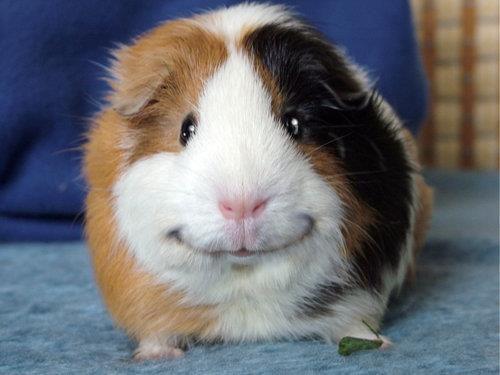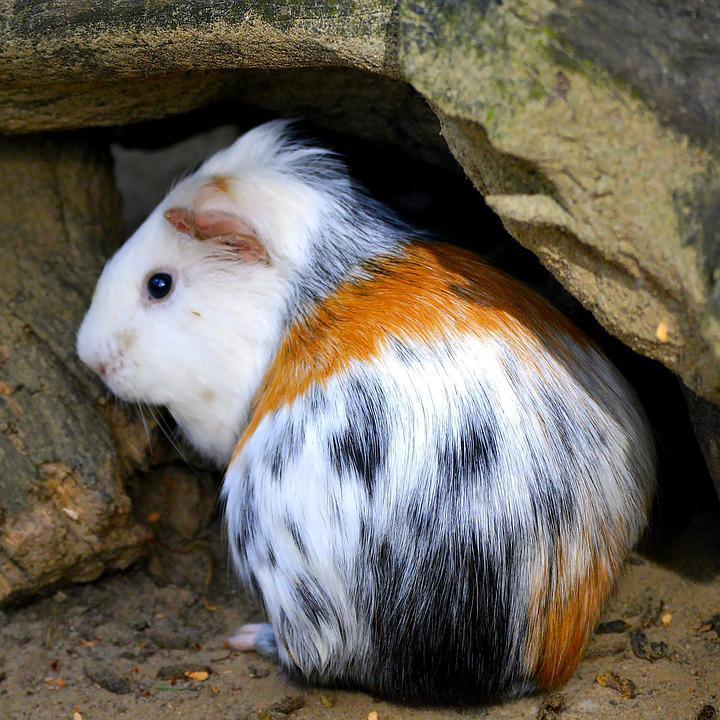The first image is the image on the left, the second image is the image on the right. Analyze the images presented: Is the assertion "One image shows real guinea pigs of various types with different fur styles, and the other image contains just one figure with a guinea pig face." valid? Answer yes or no. No. 